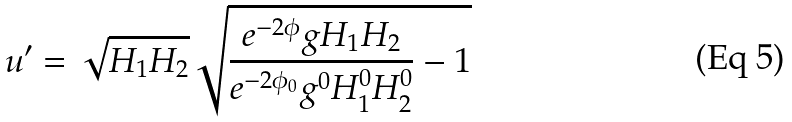<formula> <loc_0><loc_0><loc_500><loc_500>u ^ { \prime } = \sqrt { H _ { 1 } H _ { 2 } } \sqrt { \frac { e ^ { - 2 \phi } g H _ { 1 } H _ { 2 } } { e ^ { - 2 \phi _ { 0 } } g ^ { 0 } H _ { 1 } ^ { 0 } H _ { 2 } ^ { 0 } } - 1 }</formula> 